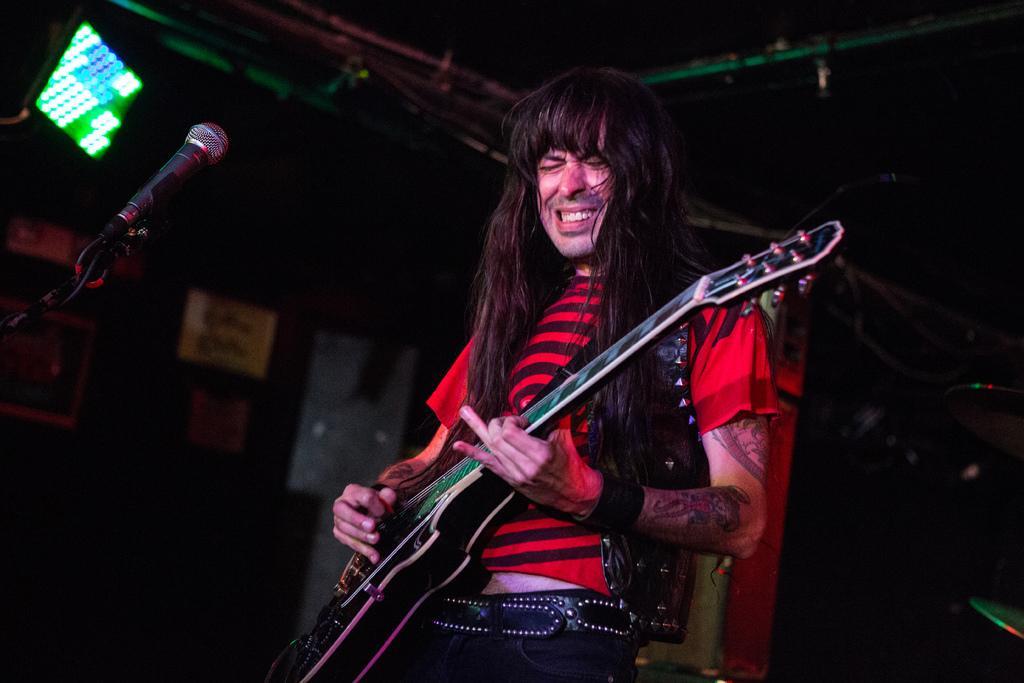Describe this image in one or two sentences. Background is really dark. This is a light. Here we can see one man with long hair standing in front of a mike singing and playing guitar. At the right side of the picture we can see cymbals, musical instrument. 